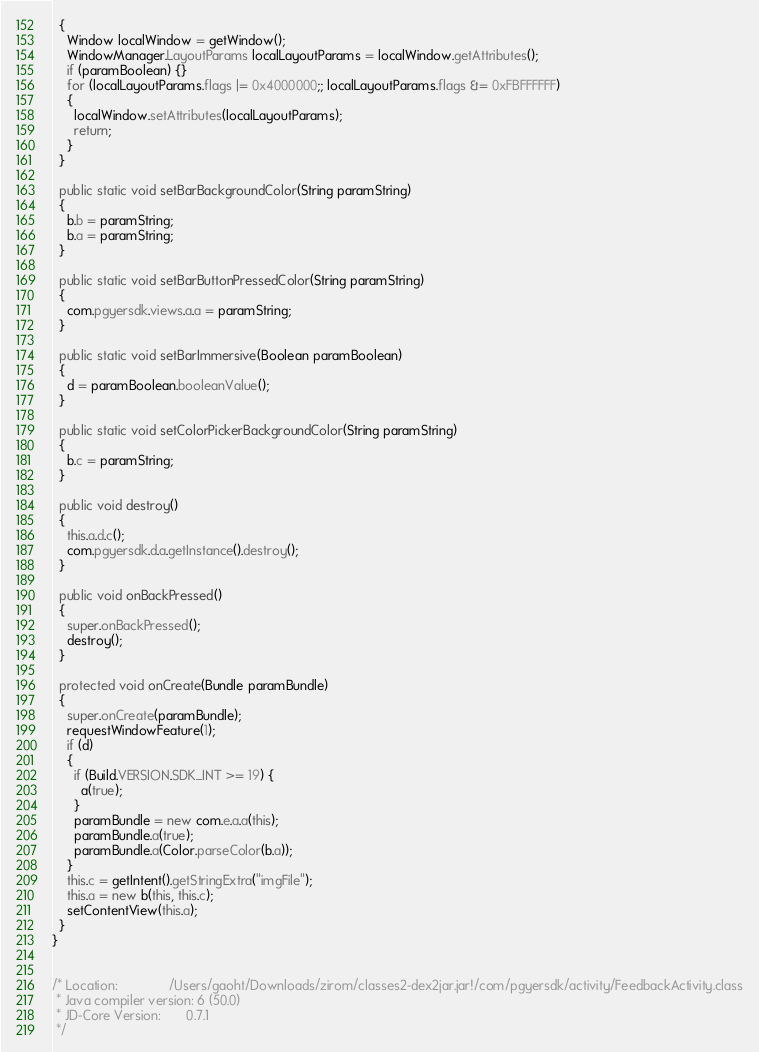Convert code to text. <code><loc_0><loc_0><loc_500><loc_500><_Java_>  {
    Window localWindow = getWindow();
    WindowManager.LayoutParams localLayoutParams = localWindow.getAttributes();
    if (paramBoolean) {}
    for (localLayoutParams.flags |= 0x4000000;; localLayoutParams.flags &= 0xFBFFFFFF)
    {
      localWindow.setAttributes(localLayoutParams);
      return;
    }
  }
  
  public static void setBarBackgroundColor(String paramString)
  {
    b.b = paramString;
    b.a = paramString;
  }
  
  public static void setBarButtonPressedColor(String paramString)
  {
    com.pgyersdk.views.a.a = paramString;
  }
  
  public static void setBarImmersive(Boolean paramBoolean)
  {
    d = paramBoolean.booleanValue();
  }
  
  public static void setColorPickerBackgroundColor(String paramString)
  {
    b.c = paramString;
  }
  
  public void destroy()
  {
    this.a.d.c();
    com.pgyersdk.d.a.getInstance().destroy();
  }
  
  public void onBackPressed()
  {
    super.onBackPressed();
    destroy();
  }
  
  protected void onCreate(Bundle paramBundle)
  {
    super.onCreate(paramBundle);
    requestWindowFeature(1);
    if (d)
    {
      if (Build.VERSION.SDK_INT >= 19) {
        a(true);
      }
      paramBundle = new com.e.a.a(this);
      paramBundle.a(true);
      paramBundle.a(Color.parseColor(b.a));
    }
    this.c = getIntent().getStringExtra("imgFile");
    this.a = new b(this, this.c);
    setContentView(this.a);
  }
}


/* Location:              /Users/gaoht/Downloads/zirom/classes2-dex2jar.jar!/com/pgyersdk/activity/FeedbackActivity.class
 * Java compiler version: 6 (50.0)
 * JD-Core Version:       0.7.1
 */</code> 